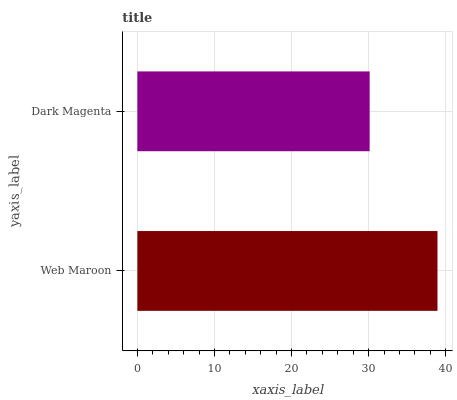Is Dark Magenta the minimum?
Answer yes or no. Yes. Is Web Maroon the maximum?
Answer yes or no. Yes. Is Dark Magenta the maximum?
Answer yes or no. No. Is Web Maroon greater than Dark Magenta?
Answer yes or no. Yes. Is Dark Magenta less than Web Maroon?
Answer yes or no. Yes. Is Dark Magenta greater than Web Maroon?
Answer yes or no. No. Is Web Maroon less than Dark Magenta?
Answer yes or no. No. Is Web Maroon the high median?
Answer yes or no. Yes. Is Dark Magenta the low median?
Answer yes or no. Yes. Is Dark Magenta the high median?
Answer yes or no. No. Is Web Maroon the low median?
Answer yes or no. No. 